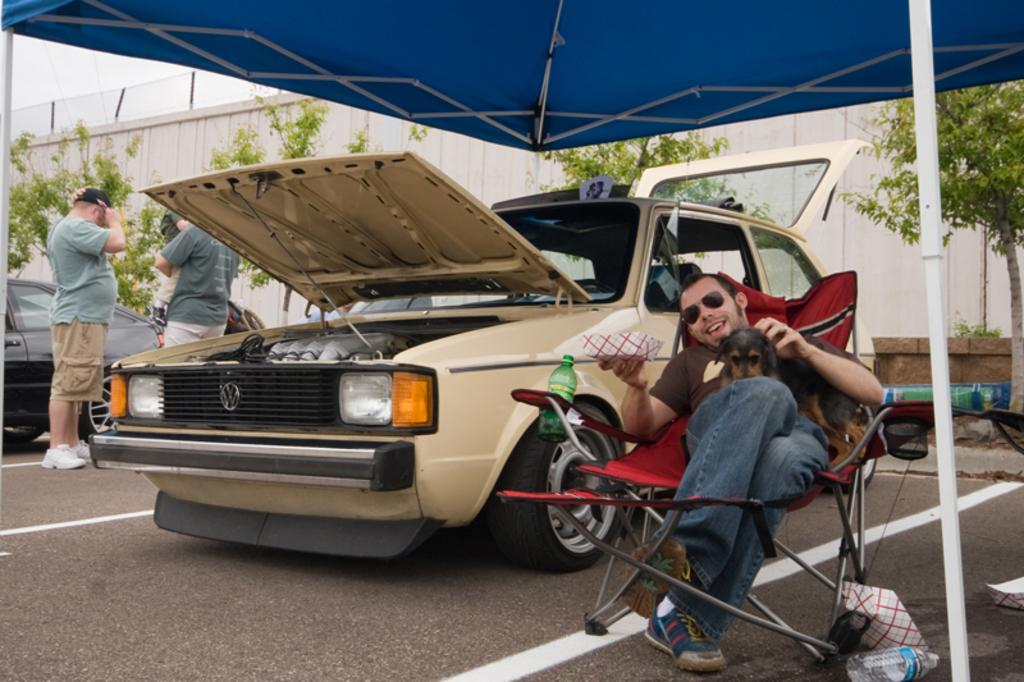What is the man in the image doing? The man is sitting in a chair and holding a dog. What else can be seen in the image besides the man and the dog? There are cars, people, plants, and a wall visible in the image. How many kittens are playing on the man's wrist in the image? There are no kittens present in the image, and the man's wrist is not visible. What type of creature is interacting with the man in the image? The man is holding a dog, which is the only creature visible in the image. 